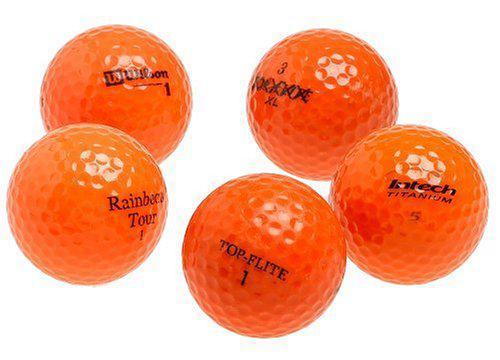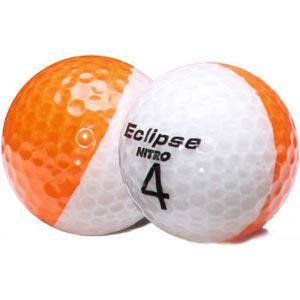The first image is the image on the left, the second image is the image on the right. For the images displayed, is the sentence "Atleast one image has a pure white ball" factually correct? Answer yes or no. No. The first image is the image on the left, the second image is the image on the right. Evaluate the accuracy of this statement regarding the images: "There are exactly two golf balls painted with half of one color and half of another color.". Is it true? Answer yes or no. Yes. 